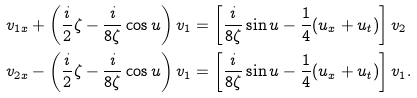<formula> <loc_0><loc_0><loc_500><loc_500>v _ { 1 x } + \left ( \frac { i } { 2 } \zeta - \frac { i } { 8 \zeta } \cos u \right ) v _ { 1 } & = \left [ \frac { i } { 8 \zeta } \sin u - \frac { 1 } { 4 } ( u _ { x } + u _ { t } ) \right ] v _ { 2 } \\ v _ { 2 x } - \left ( \frac { i } { 2 } \zeta - \frac { i } { 8 \zeta } \cos u \right ) v _ { 1 } & = \left [ \frac { i } { 8 \zeta } \sin u - \frac { 1 } { 4 } ( u _ { x } + u _ { t } ) \right ] v _ { 1 } .</formula> 